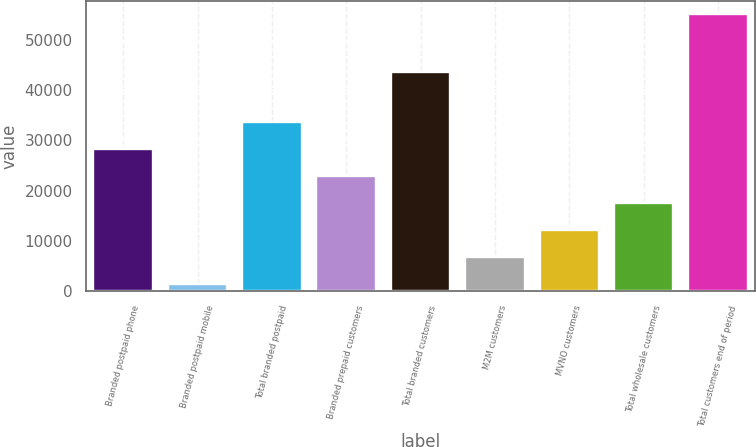Convert chart. <chart><loc_0><loc_0><loc_500><loc_500><bar_chart><fcel>Branded postpaid phone<fcel>Branded postpaid mobile<fcel>Total branded postpaid<fcel>Branded prepaid customers<fcel>Total branded customers<fcel>M2M customers<fcel>MVNO customers<fcel>Total wholesale customers<fcel>Total customers end of period<nl><fcel>28179.5<fcel>1341<fcel>33547.2<fcel>22811.8<fcel>43501<fcel>6708.7<fcel>12076.4<fcel>17444.1<fcel>55018<nl></chart> 